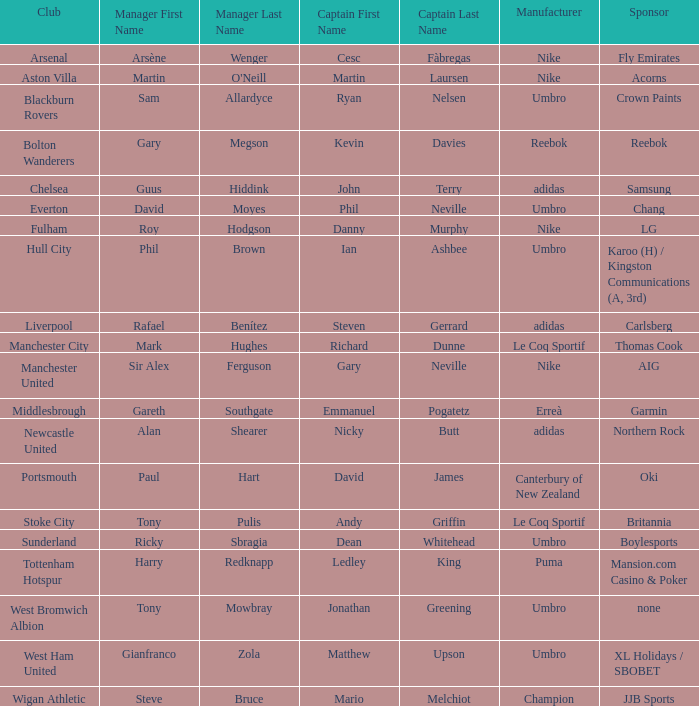I'm looking to parse the entire table for insights. Could you assist me with that? {'header': ['Club', 'Manager First Name', 'Manager Last Name', 'Captain First Name', 'Captain Last Name', 'Manufacturer', 'Sponsor'], 'rows': [['Arsenal', 'Arsène', 'Wenger', 'Cesc', 'Fàbregas', 'Nike', 'Fly Emirates'], ['Aston Villa', 'Martin', "O'Neill", 'Martin', 'Laursen', 'Nike', 'Acorns'], ['Blackburn Rovers', 'Sam', 'Allardyce', 'Ryan', 'Nelsen', 'Umbro', 'Crown Paints'], ['Bolton Wanderers', 'Gary', 'Megson', 'Kevin', 'Davies', 'Reebok', 'Reebok'], ['Chelsea', 'Guus', 'Hiddink', 'John', 'Terry', 'adidas', 'Samsung'], ['Everton', 'David', 'Moyes', 'Phil', 'Neville', 'Umbro', 'Chang'], ['Fulham', 'Roy', 'Hodgson', 'Danny', 'Murphy', 'Nike', 'LG'], ['Hull City', 'Phil', 'Brown', 'Ian', 'Ashbee', 'Umbro', 'Karoo (H) / Kingston Communications (A, 3rd)'], ['Liverpool', 'Rafael', 'Benítez', 'Steven', 'Gerrard', 'adidas', 'Carlsberg'], ['Manchester City', 'Mark', 'Hughes', 'Richard', 'Dunne', 'Le Coq Sportif', 'Thomas Cook'], ['Manchester United', 'Sir Alex', 'Ferguson', 'Gary', 'Neville', 'Nike', 'AIG'], ['Middlesbrough', 'Gareth', 'Southgate', 'Emmanuel', 'Pogatetz', 'Erreà', 'Garmin'], ['Newcastle United', 'Alan', 'Shearer', 'Nicky', 'Butt', 'adidas', 'Northern Rock'], ['Portsmouth', 'Paul', 'Hart', 'David', 'James', 'Canterbury of New Zealand', 'Oki'], ['Stoke City', 'Tony', 'Pulis', 'Andy', 'Griffin', 'Le Coq Sportif', 'Britannia'], ['Sunderland', 'Ricky', 'Sbragia', 'Dean', 'Whitehead', 'Umbro', 'Boylesports'], ['Tottenham Hotspur', 'Harry', 'Redknapp', 'Ledley', 'King', 'Puma', 'Mansion.com Casino & Poker'], ['West Bromwich Albion', 'Tony', 'Mowbray', 'Jonathan', 'Greening', 'Umbro', 'none'], ['West Ham United', 'Gianfranco', 'Zola', 'Matthew', 'Upson', 'Umbro', 'XL Holidays / SBOBET'], ['Wigan Athletic', 'Steve', 'Bruce', 'Mario', 'Melchiot', 'Champion', 'JJB Sports']]} What Premier League Manager has an Adidas sponsor and a Newcastle United club? Alan Shearer. 